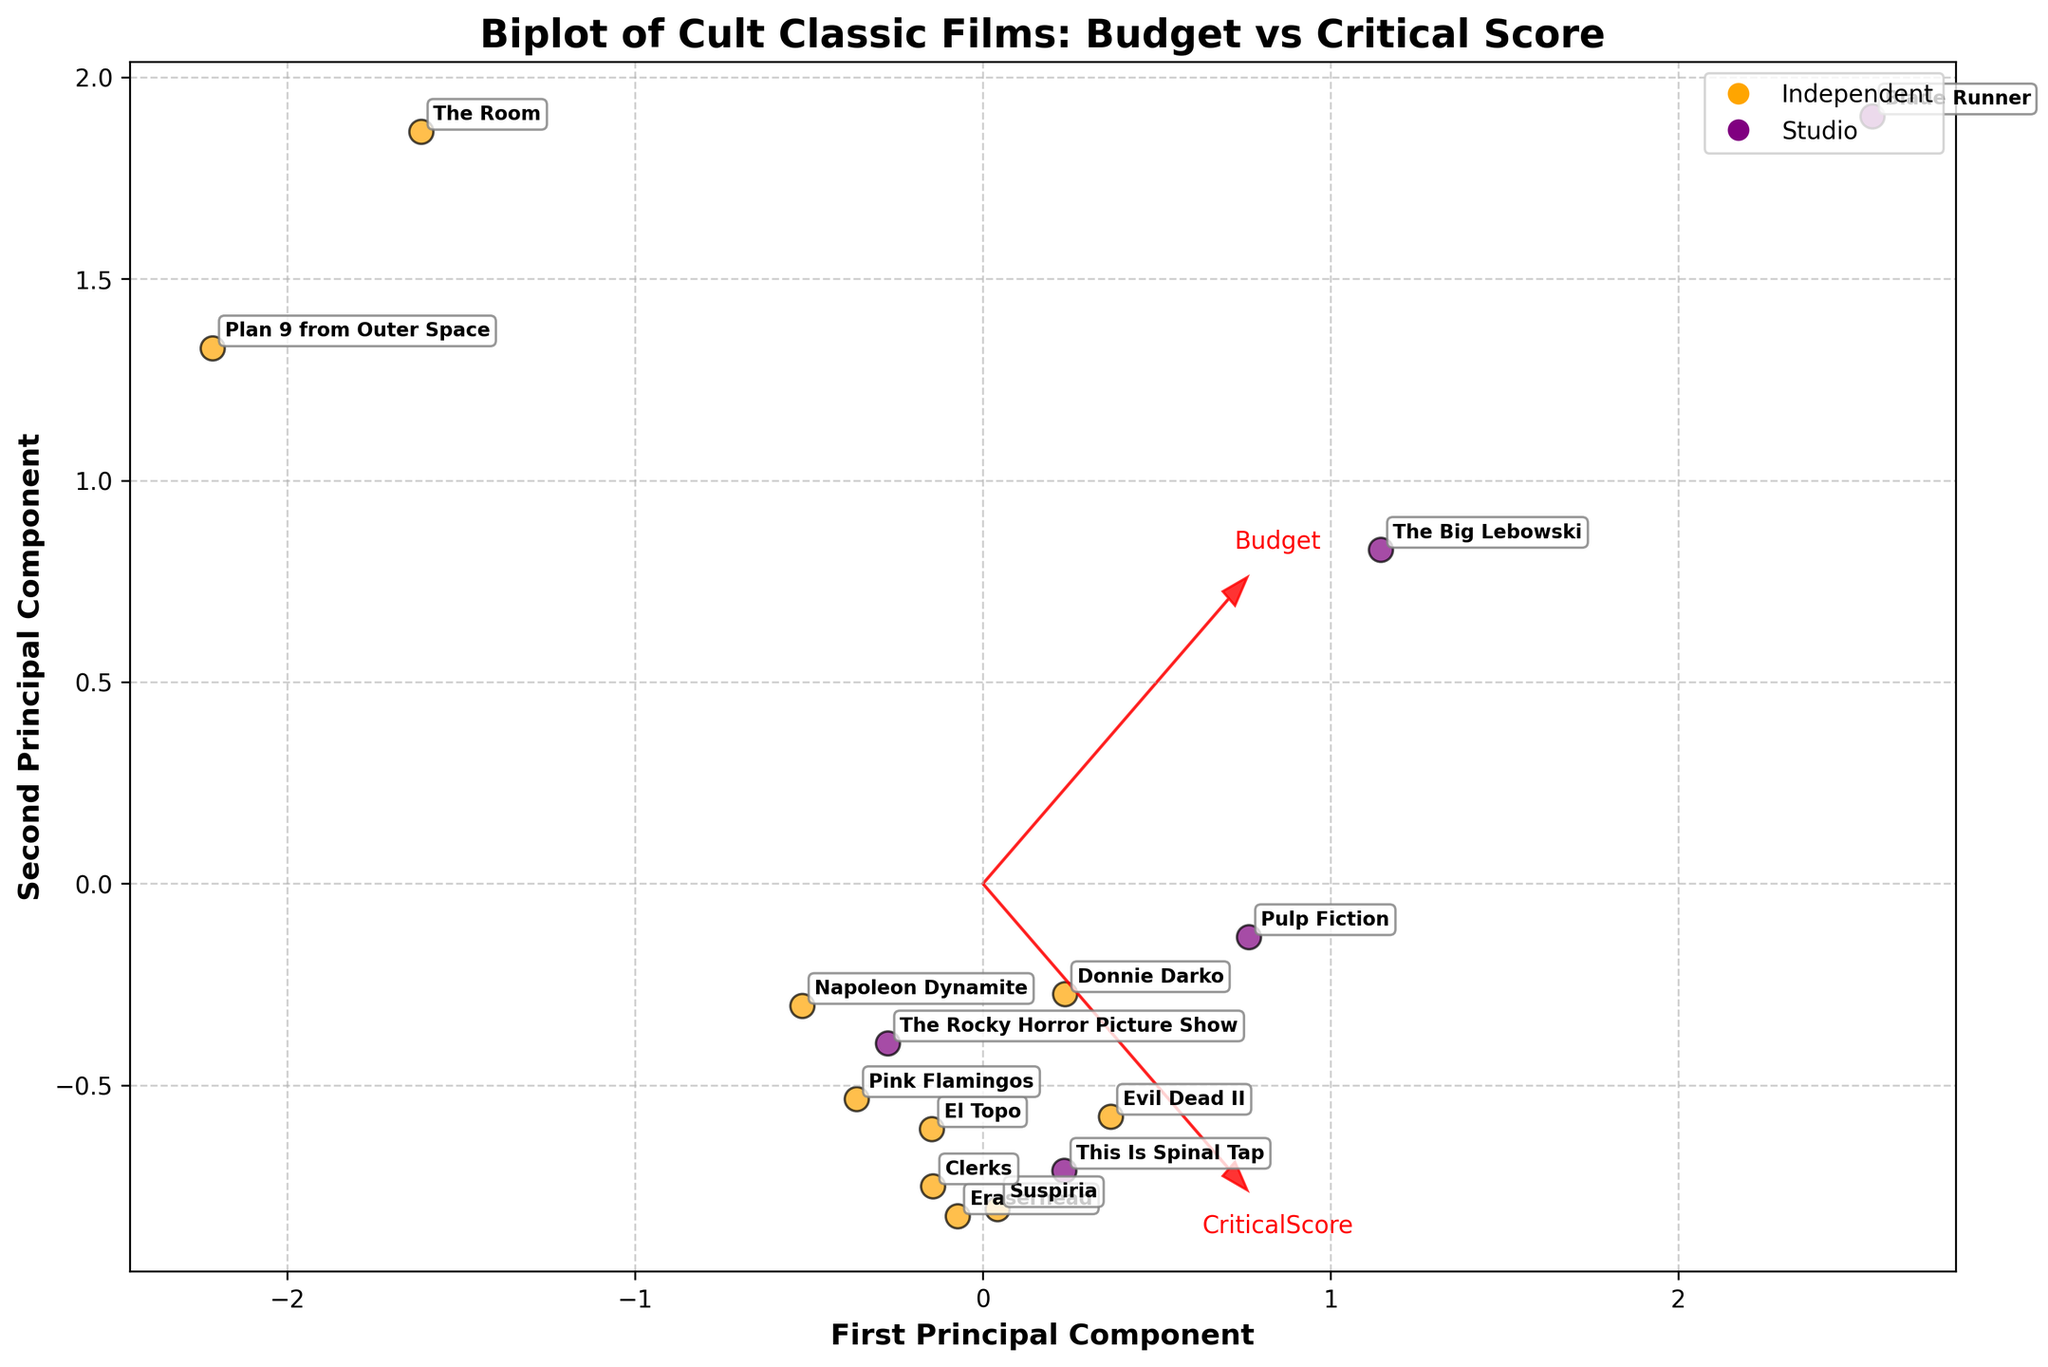What is the title of the figure? The title of the figure is usually located at the top of the plot. Here, it states "Biplot of Cult Classic Films: Budget vs Critical Score."
Answer: Biplot of Cult Classic Films: Budget vs Critical Score How many independent films are represented in the plot? To determine the number of independent films, look for data points colored in orange, which represent independent productions. Count the number of orange points annotated with film titles.
Answer: 9 Which axis represents the first principal component? The labels on the axes indicate their representation. The x-axis is labeled 'First Principal Component' to represent the first principal component.
Answer: x-axis What is the critical score of “Blade Runner”? Locate the “Blade Runner” text on the plot and see its relative position along the feature vector labeled 'CriticalScore' to find its critical score. Based on the textual data, its score aligns with 89.
Answer: 89 Which film has the highest budget among independent productions? Identify all data points colored in orange, representing independent films. Then, determine which of these points is positioned farthest along the 'Budget' vector. The Room has the position that corresponds to the largest budget.
Answer: The Room What relationship can you infer between budget and critical acclaim for independent films? Observe the placement of the orange points relative to the feature vectors. Independent films with higher budgets are spread over both high and low critical scores, indicating no straightforward correlation between budget and critical acclaim for these films.
Answer: No straightforward correlation Which type of production has more points in the positive x region of the plot? Count the number of orange (Independent) and purple (Studio) points on the right side of the plot, where the x-axis values are positive. Independent films occupy more points in this region.
Answer: Independent What does the feature vector labeled 'Budget' represent on this biplot? Feature vectors indicate the direction of increasing values for a particular variable. The 'Budget' vector shows how changes in budget quantitatively influence the principal components. This vector aids in understanding budget variations among films.
Answer: Direction of increasing budget Which film has the lowest critical score? Locate the points on the plot and identify the film label closest to the low end of the 'CriticalScore' vector. “Plan 9 from Outer Space” is near this point with the lowest critical score of 2.3.
Answer: Plan 9 from Outer Space Looking at both production types, do studio or independent films tend to receive higher critical scores? Compare the cluster of points for Studio (purple) and Independent (orange), focusing on their alignment with the 'CriticalScore' vector. Studio films generally cluster higher along this axis indicating higher scores.
Answer: Studio 